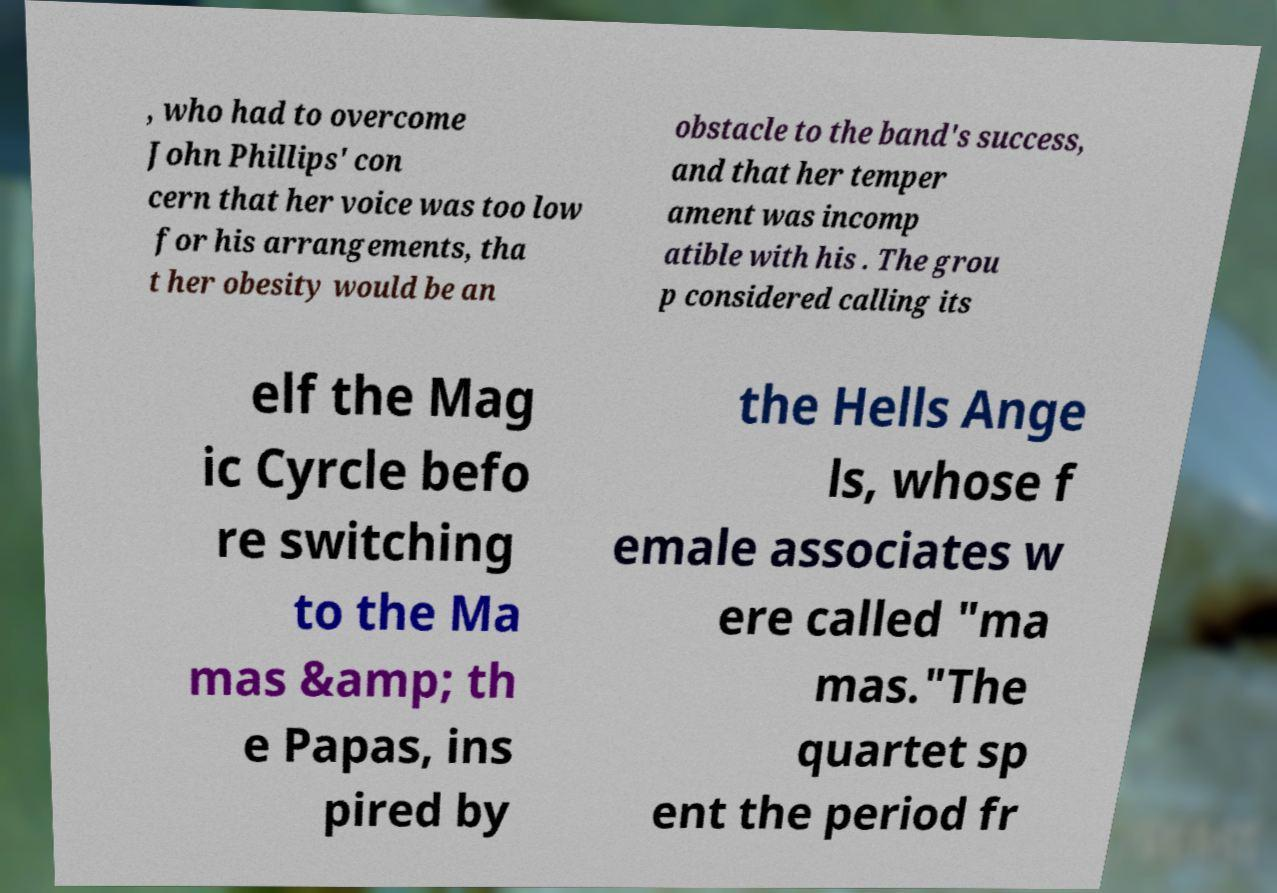Could you extract and type out the text from this image? , who had to overcome John Phillips' con cern that her voice was too low for his arrangements, tha t her obesity would be an obstacle to the band's success, and that her temper ament was incomp atible with his . The grou p considered calling its elf the Mag ic Cyrcle befo re switching to the Ma mas &amp; th e Papas, ins pired by the Hells Ange ls, whose f emale associates w ere called "ma mas."The quartet sp ent the period fr 